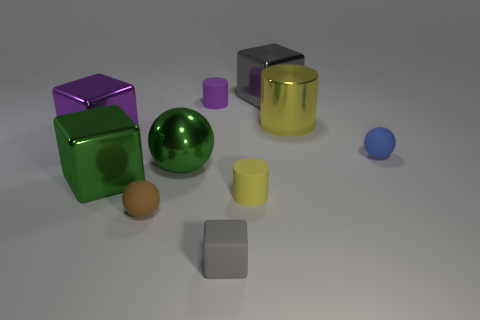What is the shape of the small yellow object that is made of the same material as the tiny blue object? The small yellow object shares its cylindrical shape and glossy material with the tiny blue object in the image. 